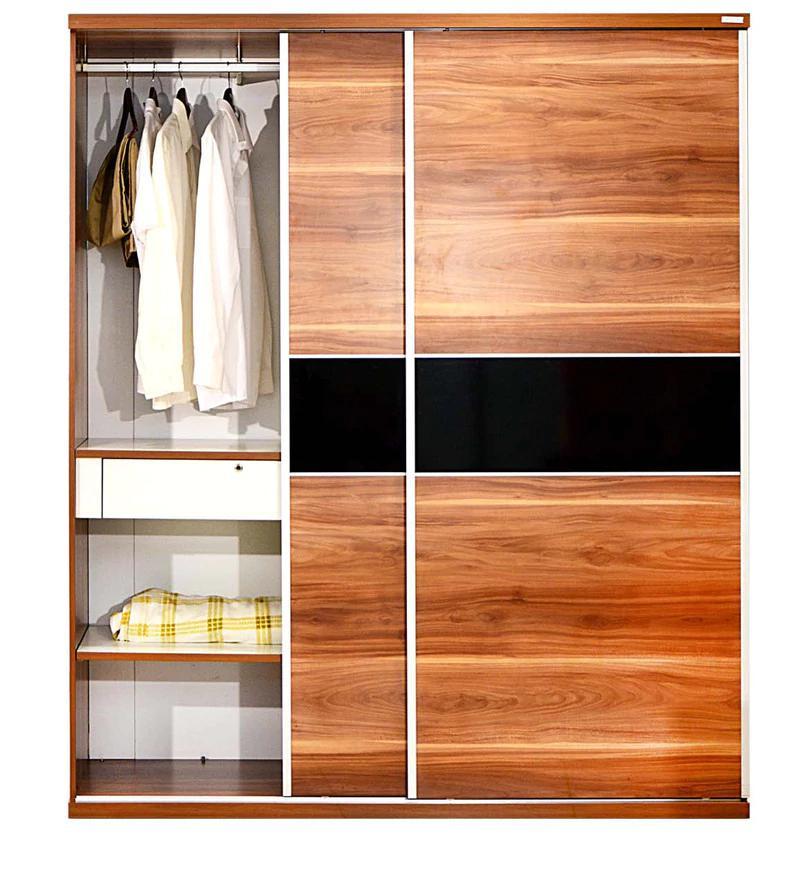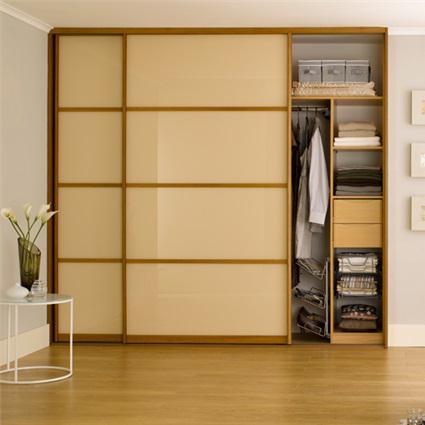The first image is the image on the left, the second image is the image on the right. Examine the images to the left and right. Is the description "One image shows a sliding wood-grain door with a black horizontal band in the center." accurate? Answer yes or no. Yes. The first image is the image on the left, the second image is the image on the right. For the images shown, is this caption "In one image, a wooden free-standing wardrobe has sliding doors, one of which is open." true? Answer yes or no. Yes. 